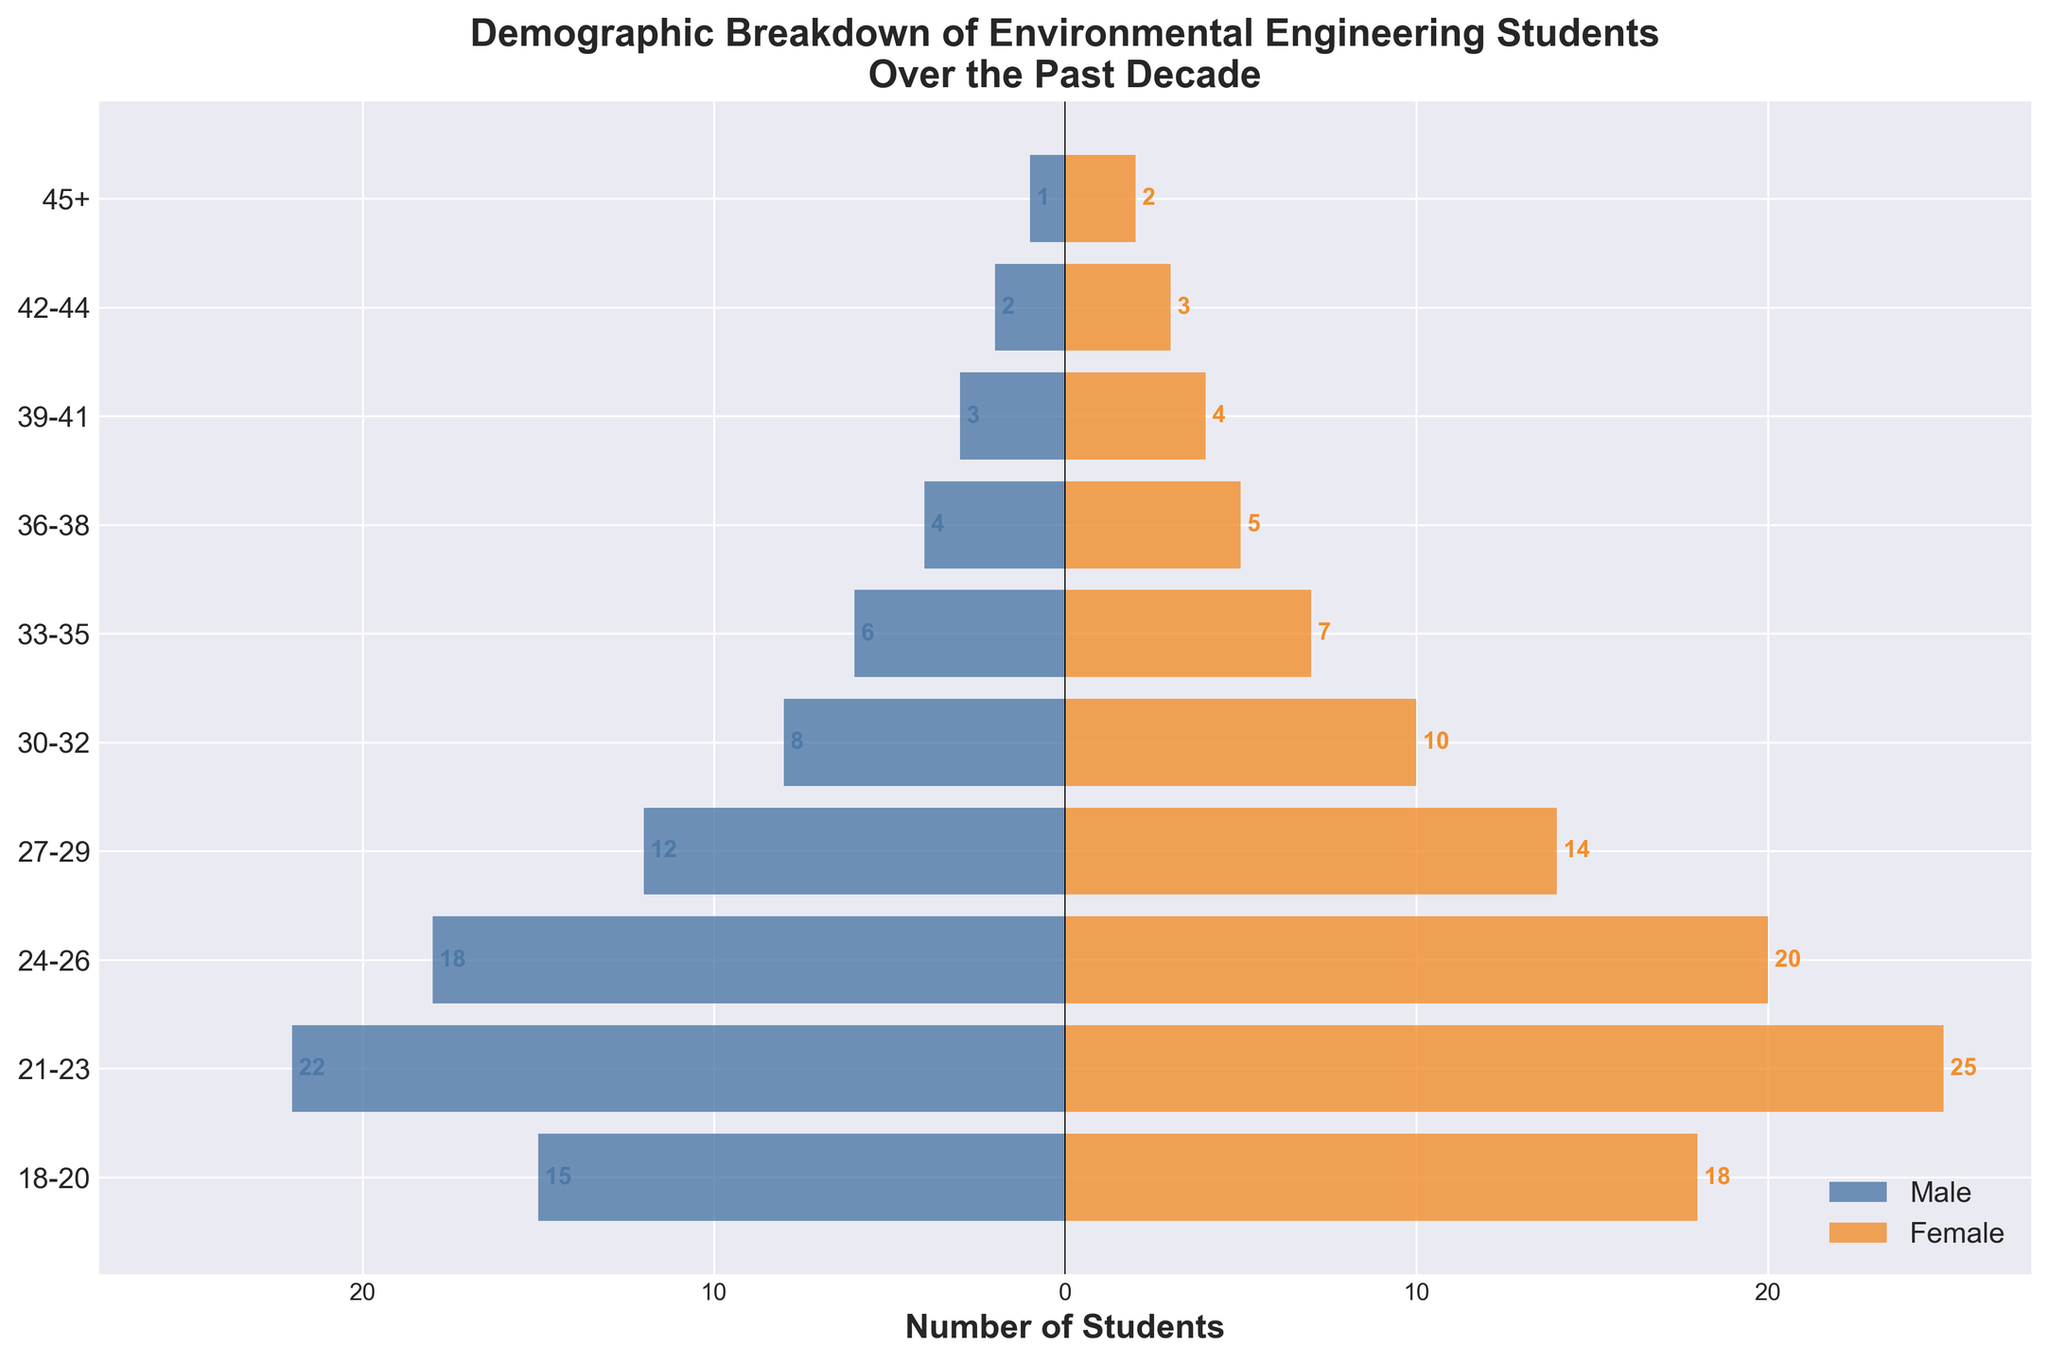What is the title of the figure? The title of the figure is usually located at the top center and summarizes what the figure is about. From that information, you can find the complete title.
Answer: Demographic Breakdown of Environmental Engineering Students Over the Past Decade What are the colors used to represent male and female students? The colors used for different categories in the bar chart are typically listed in the legend. Here, the legend indicates that blue represents male students and orange represents female students.
Answer: Blue and Orange How many students aged 21-23 are enrolled in the program? To find the total number of students in the 21-23 age group, you need to sum the number of male and female students in that age group.
Answer: 47 Which age group has the highest total number of students? To identify the age group with the highest total number of students, sum the male and female students for each age group and compare those sums.
Answer: 21-23 What is the difference in the number of male and female students in the 24-26 age group? Subtract the number of male students from the number of female students in the 24-26 age group. Here, 20 (female) - 18 (male).
Answer: 2 Are there more students aged 27-29 or 18-20? Compare the total number of students in each age group by summing the male and female students for both.
Answer: 18-20 In which age group is the ratio of female to male students the highest? Calculate the ratio of female to male students for each age group and compare them. The ratio is highest where this calculation yields the largest value.
Answer: 45+ What is the total number of students aged 30-32 and 33-35 combined? Add the total number of students (both male and female) in the 30-32 and 33-35 age groups.
Answer: 31 Which age group has the least number of male students? Compare the numbers of male students across all age groups, and identify the one with the lowest value.
Answer: 45+ How does the trend of student enrollment change with increasing age? Observe the general pattern of the bars representing male and female students as age increases. Here, student enrollment usually decreases with age.
Answer: Decreases 